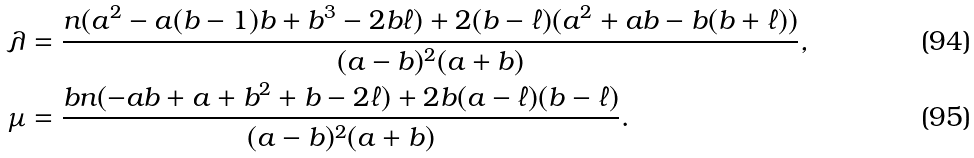Convert formula to latex. <formula><loc_0><loc_0><loc_500><loc_500>\lambda & = \frac { n ( a ^ { 2 } - a ( b - 1 ) b + b ^ { 3 } - 2 b \ell ) + 2 ( b - \ell ) ( a ^ { 2 } + a b - b ( b + \ell ) ) } { ( a - b ) ^ { 2 } ( a + b ) } , \\ \mu & = \frac { b n ( - a b + a + b ^ { 2 } + b - 2 \ell ) + 2 b ( a - \ell ) ( b - \ell ) } { ( a - b ) ^ { 2 } ( a + b ) } .</formula> 